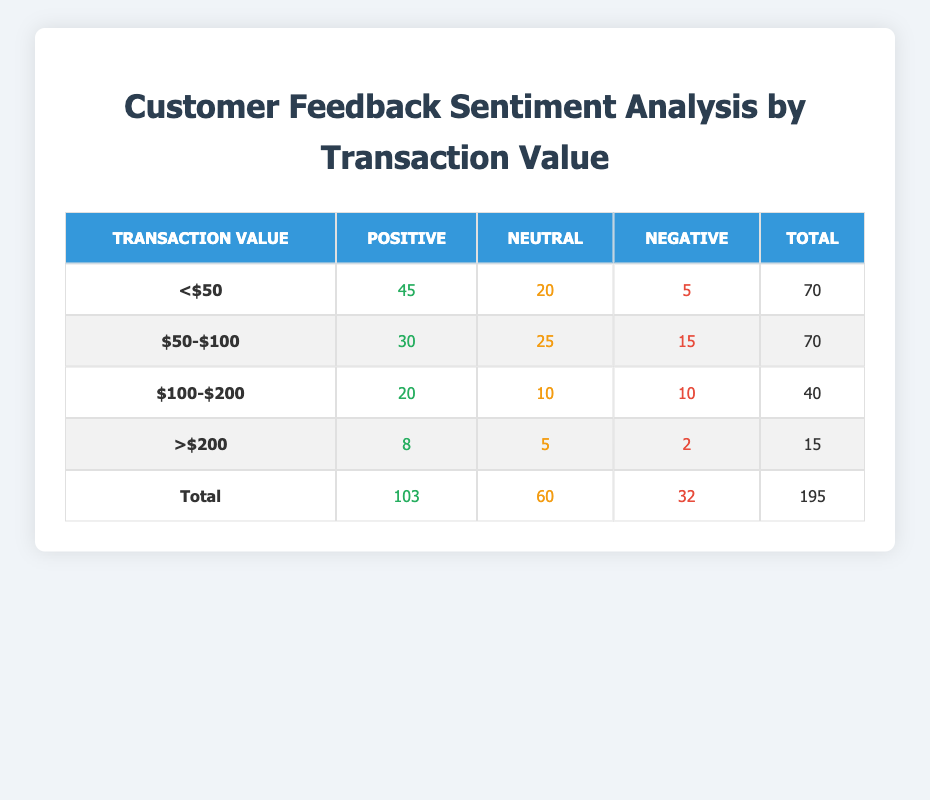What is the total count of positive sentiments for transactions below $50? The positive sentiment count for transactions below $50 is given directly in the table as 45.
Answer: 45 How many negative sentiments are there for transactions between $50 and $100? The negative sentiment count for transactions between $50 and $100 is provided in the table as 15.
Answer: 15 What is the average count of neutral sentiments across all transaction values? To find the average, we first sum the neutral counts: 20 (below $50) + 25 ($50-$100) + 10 ($100-$200) + 5 (above $200) = 60. There are 4 transaction categories, so the average is 60/4 = 15.
Answer: 15 Is the total number of negative sentiments greater than the total number of positive sentiments? The total number of negative sentiments is 32 (from all ranges) and the total positive sentiments is 103. Since 32 is less than 103, the statement is false.
Answer: No What is the difference in positive sentiment counts between transactions below $50 and those between $50 and $100? The positive sentiment for below $50 is 45 and for $50-$100 is 30. The difference is calculated as 45 - 30 = 15.
Answer: 15 How many total feedback counts are there for transactions greater than $200? The total feedback counts for transactions greater than $200 can be found by summing the counts in that row: 8 (positive) + 5 (neutral) + 2 (negative) = 15.
Answer: 15 Which transaction value category has the highest number of neutral sentiments? By looking at the neutral counts: 20 (below $50), 25 ($50-$100), 10 ($100-$200), and 5 (above $200), the highest is 25 for the $50-$100 category.
Answer: $50-$100 What proportion of total feedback is positive? The total positive feedback is 103 and the overall total feedback is 195. The proportion is 103/195, which is approximately 0.528 or 52.8 percent.
Answer: 52.8 percent 